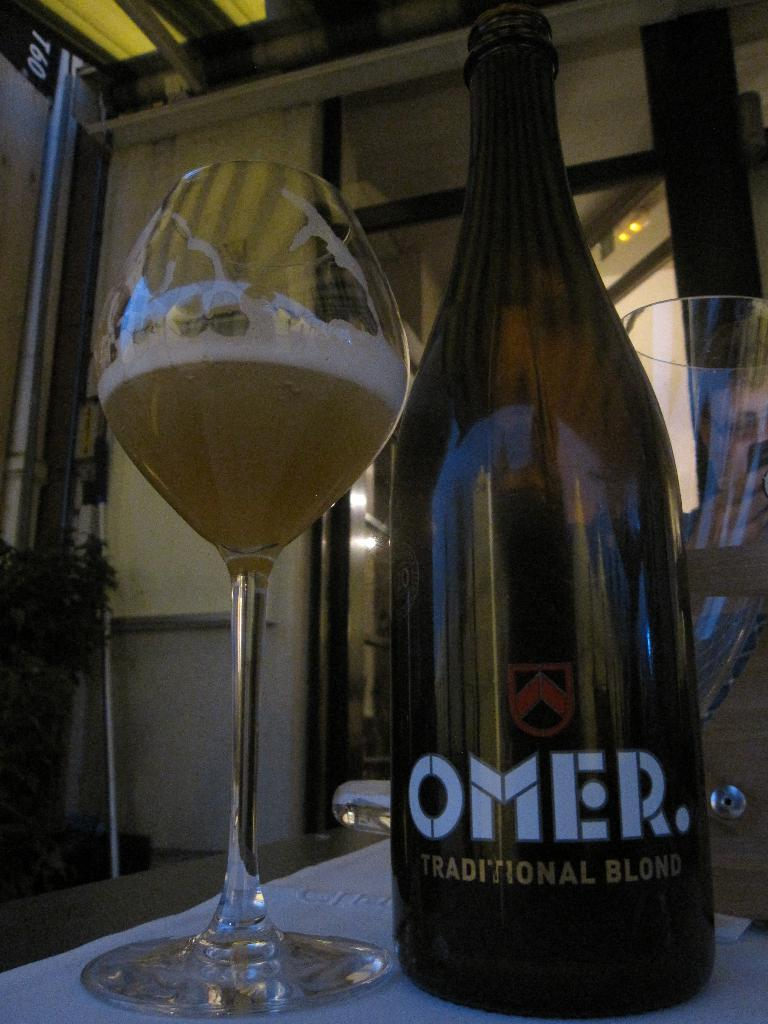What piece of furniture is present in the image? There is a table in the image. What is placed on the table? There is a glass and a bottle on the table. What color is the duck in the image? There is no duck present in the image. What type of rail is visible in the image? There is no rail present in the image. 